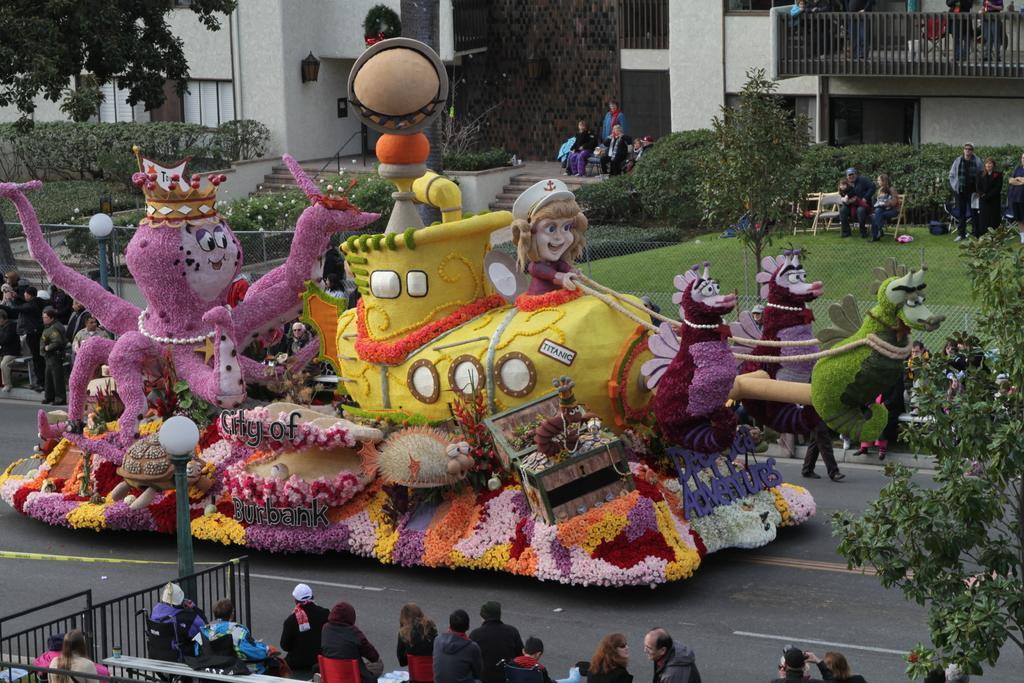In one or two sentences, can you explain what this image depicts? In the center of the image we can see a rose parade. In the background there are people sitting and some of them are standing. At the bottom there is crowd and we can see gates. There is a pole we can see buildings, trees, bushes and stairs and we can see a road. 